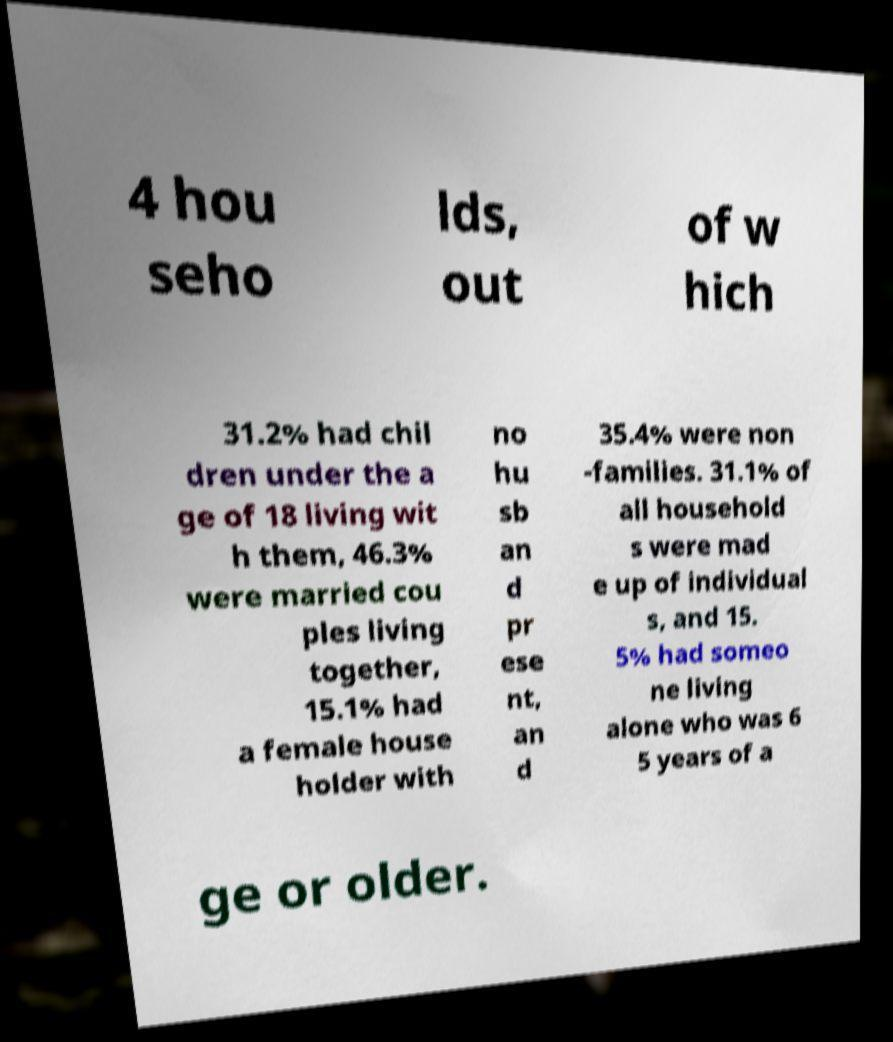There's text embedded in this image that I need extracted. Can you transcribe it verbatim? 4 hou seho lds, out of w hich 31.2% had chil dren under the a ge of 18 living wit h them, 46.3% were married cou ples living together, 15.1% had a female house holder with no hu sb an d pr ese nt, an d 35.4% were non -families. 31.1% of all household s were mad e up of individual s, and 15. 5% had someo ne living alone who was 6 5 years of a ge or older. 